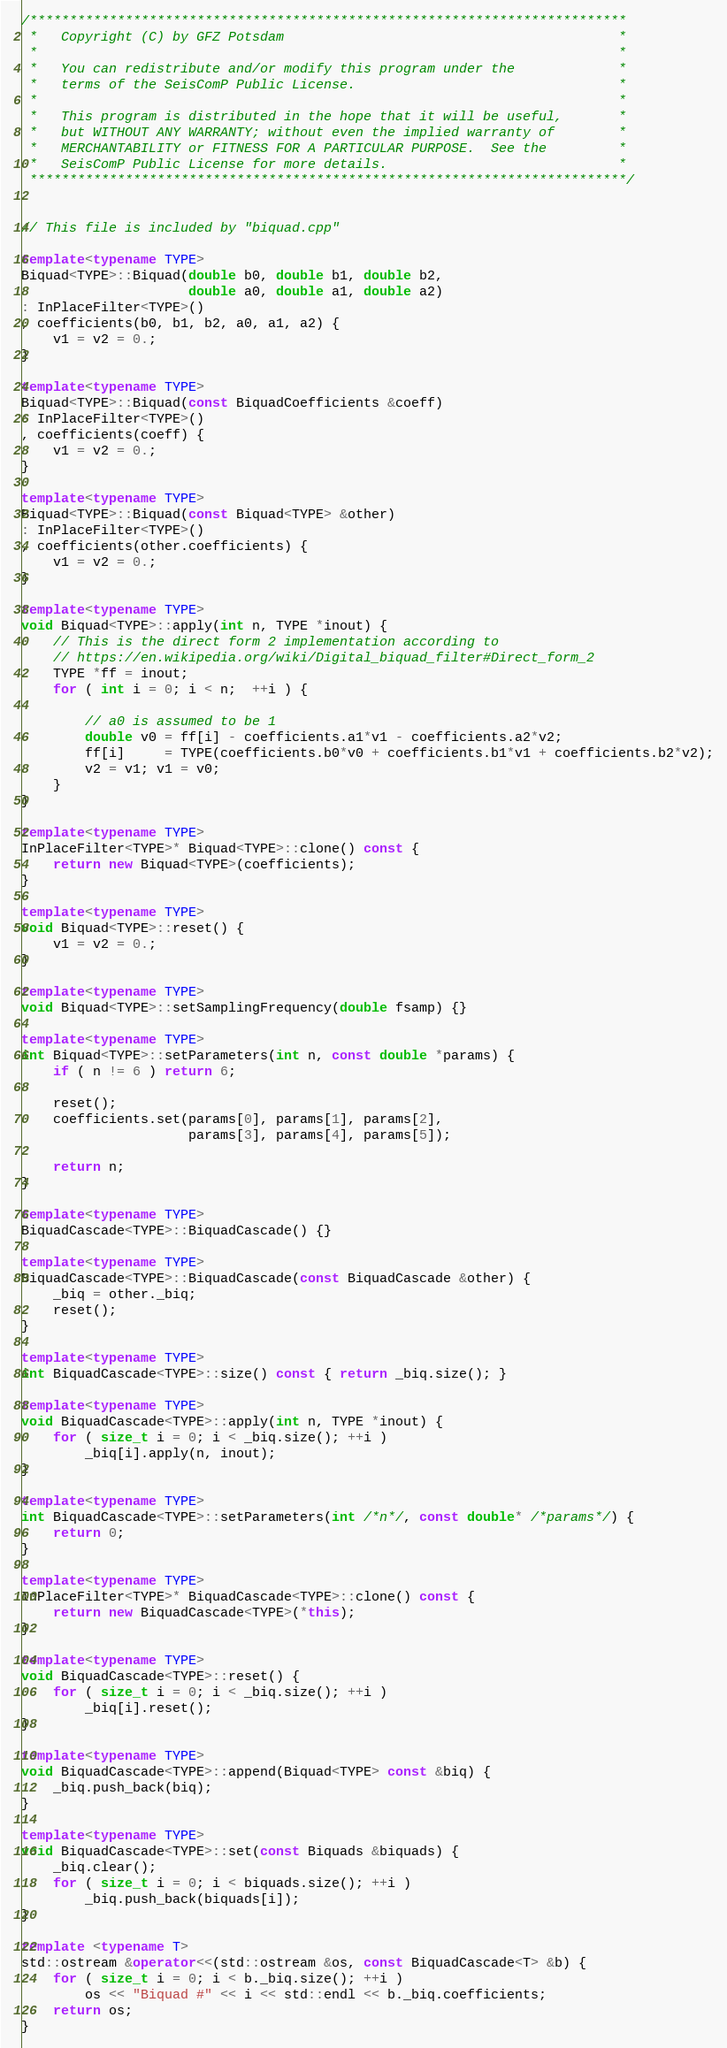Convert code to text. <code><loc_0><loc_0><loc_500><loc_500><_C++_>/***************************************************************************
 *   Copyright (C) by GFZ Potsdam                                          *
 *                                                                         *
 *   You can redistribute and/or modify this program under the             *
 *   terms of the SeisComP Public License.                                 *
 *                                                                         *
 *   This program is distributed in the hope that it will be useful,       *
 *   but WITHOUT ANY WARRANTY; without even the implied warranty of        *
 *   MERCHANTABILITY or FITNESS FOR A PARTICULAR PURPOSE.  See the         *
 *   SeisComP Public License for more details.                             *
 ***************************************************************************/


// This file is included by "biquad.cpp"

template<typename TYPE>
Biquad<TYPE>::Biquad(double b0, double b1, double b2,
                     double a0, double a1, double a2)
: InPlaceFilter<TYPE>()
, coefficients(b0, b1, b2, a0, a1, a2) {
	v1 = v2 = 0.;
}

template<typename TYPE>
Biquad<TYPE>::Biquad(const BiquadCoefficients &coeff)
: InPlaceFilter<TYPE>()
, coefficients(coeff) {
	v1 = v2 = 0.;
}

template<typename TYPE>
Biquad<TYPE>::Biquad(const Biquad<TYPE> &other)
: InPlaceFilter<TYPE>()
, coefficients(other.coefficients) {
	v1 = v2 = 0.;
}

template<typename TYPE>
void Biquad<TYPE>::apply(int n, TYPE *inout) {
	// This is the direct form 2 implementation according to
	// https://en.wikipedia.org/wiki/Digital_biquad_filter#Direct_form_2
	TYPE *ff = inout;
	for ( int i = 0; i < n;  ++i ) {

		// a0 is assumed to be 1
		double v0 = ff[i] - coefficients.a1*v1 - coefficients.a2*v2;
		ff[i]     = TYPE(coefficients.b0*v0 + coefficients.b1*v1 + coefficients.b2*v2);
		v2 = v1; v1 = v0;
	}
}

template<typename TYPE>
InPlaceFilter<TYPE>* Biquad<TYPE>::clone() const {
	return new Biquad<TYPE>(coefficients);
}

template<typename TYPE>
void Biquad<TYPE>::reset() {
	v1 = v2 = 0.;
}

template<typename TYPE>
void Biquad<TYPE>::setSamplingFrequency(double fsamp) {}

template<typename TYPE>
int Biquad<TYPE>::setParameters(int n, const double *params) {
	if ( n != 6 ) return 6;

	reset();
	coefficients.set(params[0], params[1], params[2],
	                 params[3], params[4], params[5]);

	return n;
}

template<typename TYPE>
BiquadCascade<TYPE>::BiquadCascade() {}

template<typename TYPE>
BiquadCascade<TYPE>::BiquadCascade(const BiquadCascade &other) {
	_biq = other._biq;
	reset();
}

template<typename TYPE>
int BiquadCascade<TYPE>::size() const { return _biq.size(); }

template<typename TYPE>
void BiquadCascade<TYPE>::apply(int n, TYPE *inout) {
	for ( size_t i = 0; i < _biq.size(); ++i )
		_biq[i].apply(n, inout);
}

template<typename TYPE>
int BiquadCascade<TYPE>::setParameters(int /*n*/, const double* /*params*/) {
	return 0;
}

template<typename TYPE>
InPlaceFilter<TYPE>* BiquadCascade<TYPE>::clone() const {
	return new BiquadCascade<TYPE>(*this);
}

template<typename TYPE>
void BiquadCascade<TYPE>::reset() {
	for ( size_t i = 0; i < _biq.size(); ++i )
		_biq[i].reset();
}

template<typename TYPE>
void BiquadCascade<TYPE>::append(Biquad<TYPE> const &biq) {
	_biq.push_back(biq);
}

template<typename TYPE>
void BiquadCascade<TYPE>::set(const Biquads &biquads) {
	_biq.clear();
	for ( size_t i = 0; i < biquads.size(); ++i )
		_biq.push_back(biquads[i]);
}

template <typename T>
std::ostream &operator<<(std::ostream &os, const BiquadCascade<T> &b) {
	for ( size_t i = 0; i < b._biq.size(); ++i )
		os << "Biquad #" << i << std::endl << b._biq.coefficients;
	return os;
}

</code> 